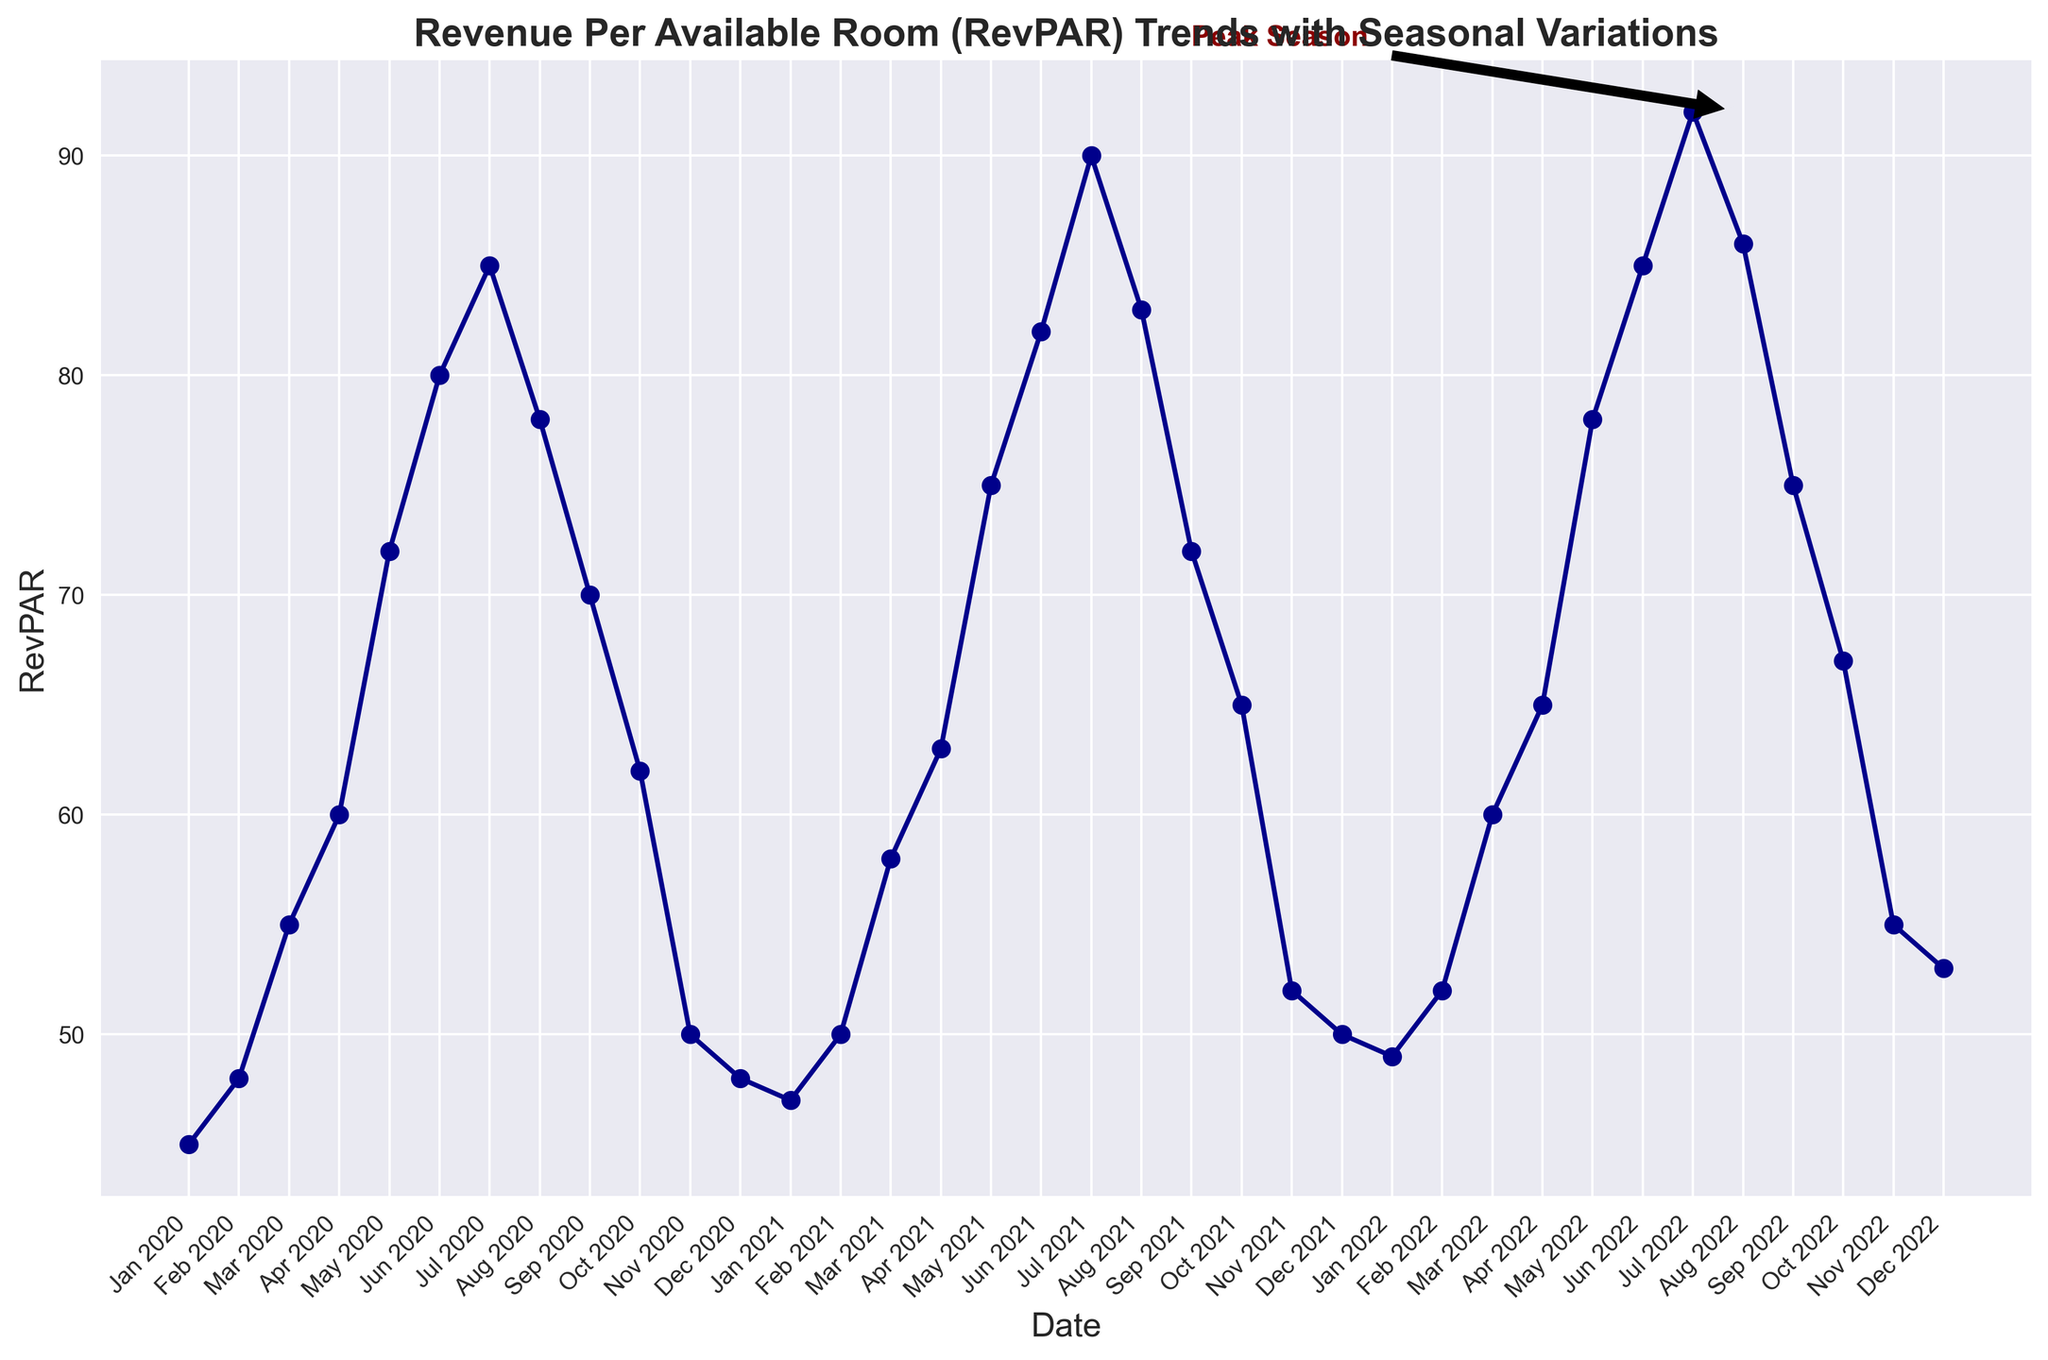What is the trend of RevPAR from Jan 2020 to Dec 2020? From the line chart, the RevPAR starts at 45 in Jan 2020 and increases to 55 in Mar 2020, peaks at 85 in Jul 2020, and then decreases to 48 in Dec 2020.
Answer: Increasing initially, peaking in summer, then decreasing During which month and year was the highest RevPAR recorded, and what was the value? The annotation "Peak Season" points to Jul 2022 with the highest RevPAR value of 92.
Answer: Jul 2022, 92 Compare the RevPAR values between Jan of each year from 2020 to 2022. What is the trend? The RevPAR values in Jan are 45 in 2020, 47 in 2021, and 49 in 2022, showing a consistent increase each year.
Answer: Consistent increase Which month consistently shows a decrease in RevPAR after the peak summer season? After the summer peak in Jul, the RevPAR consistently decreases in Aug, and the trend continues into Sep for all three years.
Answer: Aug and Sep How does the RevPAR value in May of each year change from 2020 to 2022? The RevPAR values in May are 72 in 2020, 75 in 2021, and 78 in 2022, showing a slight increase each year.
Answer: Slight increase What is the difference in the RevPAR between Jun 2020 and Jun 2022? The RevPAR in Jun 2020 is 80, and in Jun 2022, it is 85. The difference is 85 - 80 = 5.
Answer: 5 What is the average RevPAR for the year 2021? Adding the monthly RevPAR values for 2021 gives 838. There are 12 months, so the average is 838/12 ≈ 69.83.
Answer: 69.83 Identify the months in each year where RevPAR is lower than 50. In 2020: Jan, Feb, Nov, Dec. In 2021: Nov, Dec. In 2022: Jan, Nov, Dec.
Answer: Jan, Feb, Nov, Dec (2020); Nov, Dec (2021); Jan, Nov, Dec (2022) Compare the peak RevPAR values in 2021 and 2022. Which year had a higher peak, and by how much? In 2021, the peak was 90 in Jul; in 2022, it was 92 in Jul. The difference is 92 - 90 = 2.
Answer: 2022, by 2 Which month shows the most significant drop in RevPAR from one month to the next in all three years? Considering the data points, the most significant drop is from Jul to Aug in each year.
Answer: Jul to Aug 